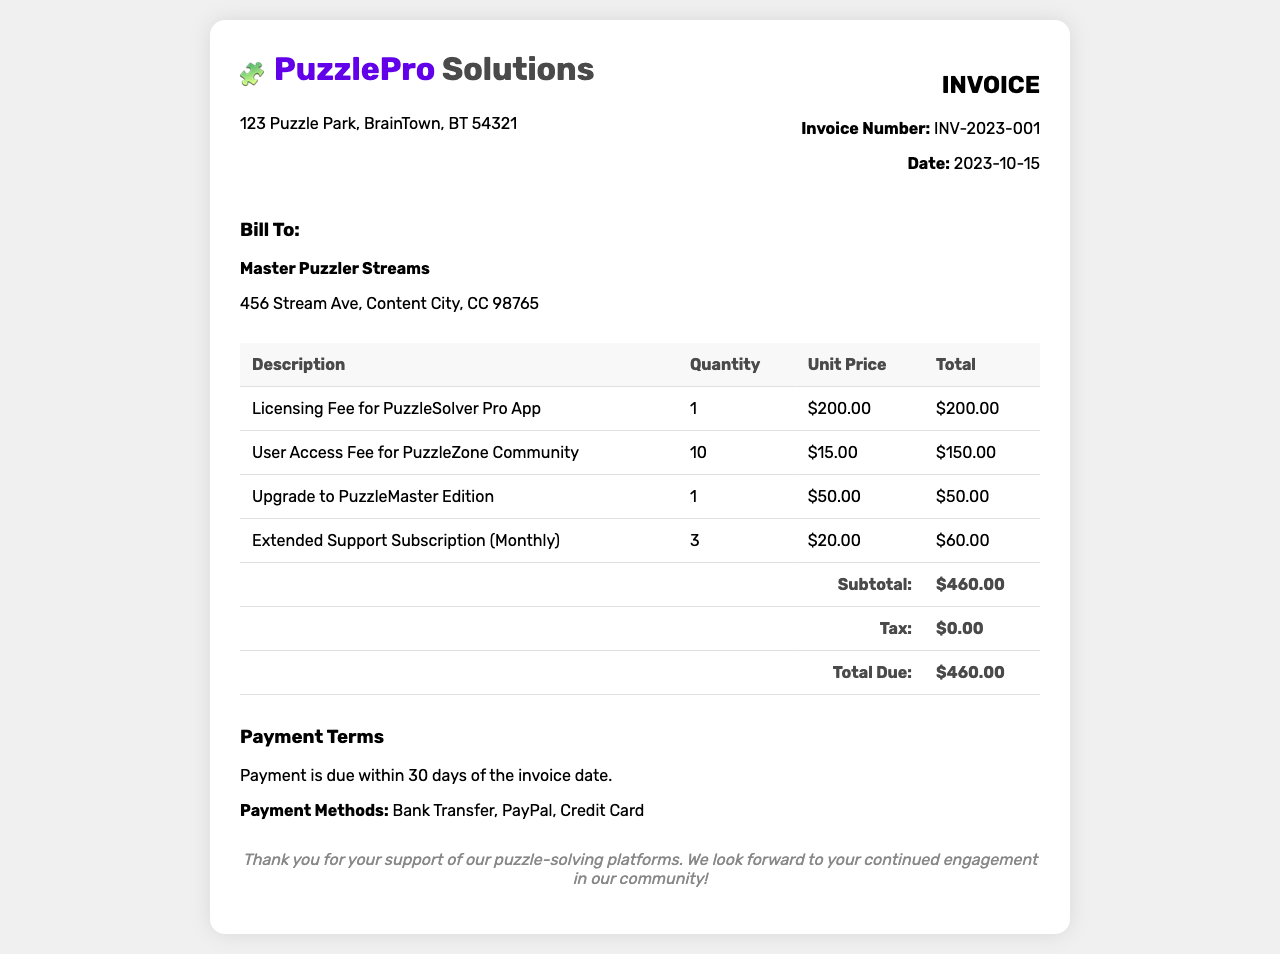What is the invoice number? The invoice number is specified in the document and is used to uniquely identify this invoice.
Answer: INV-2023-001 What is the total due amount? The total due amount is the final amount that needs to be paid as stated in the invoice.
Answer: $460.00 What is the licensing fee for the PuzzleSolver Pro App? The licensing fee for the specific app is mentioned in the line item for that service.
Answer: $200.00 How many user access fees were billed? The invoice details the quantity of user access fees charged for services.
Answer: 10 What is the date of the invoice? The date reflects when the invoice was generated and is important for billing cycles.
Answer: 2023-10-15 What is the subtotal before taxes? The subtotal is the sum of all line item amounts before any tax is applied.
Answer: $460.00 What is the quantity of the extended support subscription? The quantity indicates how many months of support services were charged on the invoice.
Answer: 3 What payment methods are accepted? The document lists the types of payment methods available for settling the invoice.
Answer: Bank Transfer, PayPal, Credit Card What is the company name on the invoice? The company name identified in the header section indicates the provider of the services.
Answer: PuzzlePro Solutions 